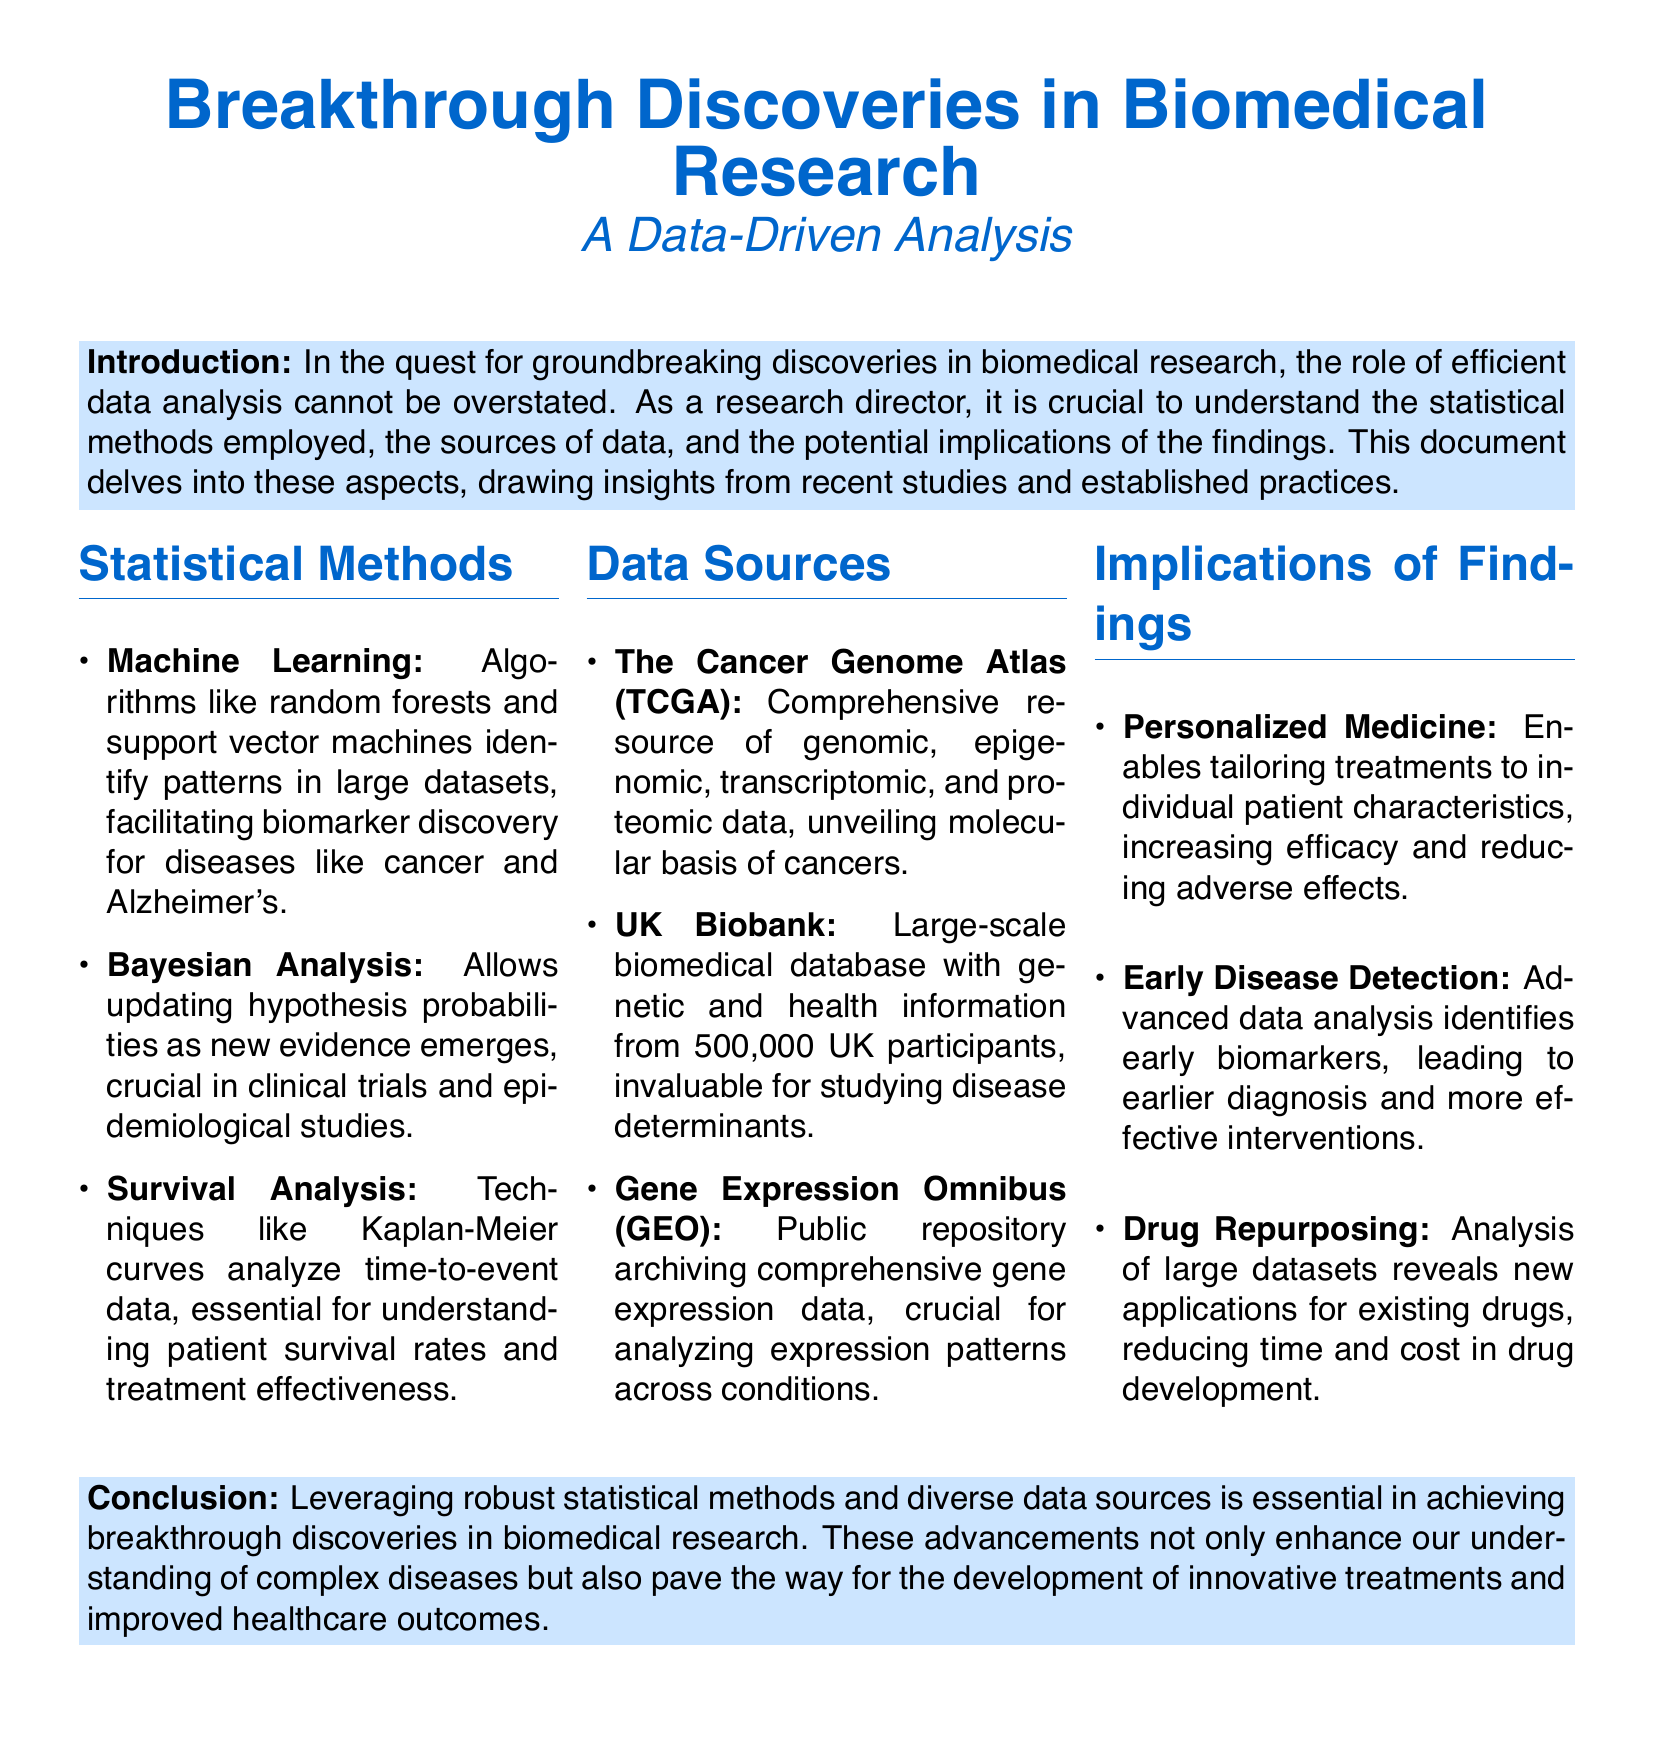What are the three statistical methods mentioned? The document lists three statistical methods: Machine Learning, Bayesian Analysis, and Survival Analysis.
Answer: Machine Learning, Bayesian Analysis, Survival Analysis How many participants are in the UK Biobank? The UK Biobank contains health information from 500,000 UK participants.
Answer: 500,000 Which data source provides genomic data specific to cancers? The Cancer Genome Atlas (TCGA) is a comprehensive resource of genomic data specifically related to cancers.
Answer: The Cancer Genome Atlas What is a key implication of early disease detection mentioned in the document? The document states that early disease detection leads to earlier diagnosis and more effective interventions.
Answer: Earlier diagnosis Which statistical method is crucial for analyzing time-to-event data? Survival Analysis techniques like Kaplan-Meier curves are essential for analyzing time-to-event data.
Answer: Survival Analysis What overarching theme is discussed in the conclusion? The conclusion emphasizes the importance of leveraging statistical methods and data sources for breakthrough discoveries in biomedical research.
Answer: Breakthrough discoveries What is one benefit of personalized medicine according to the document? The document mentions that personalized medicine enables tailoring treatments to individual patient characteristics.
Answer: Tailoring treatments Can you name one advanced data analysis outcome regarding drug development? The document discusses that analysis of large datasets reveals new applications for existing drugs, which reduces time and cost in drug development.
Answer: Drug repurposing 